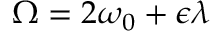Convert formula to latex. <formula><loc_0><loc_0><loc_500><loc_500>\Omega = 2 \omega _ { 0 } + \epsilon \lambda</formula> 